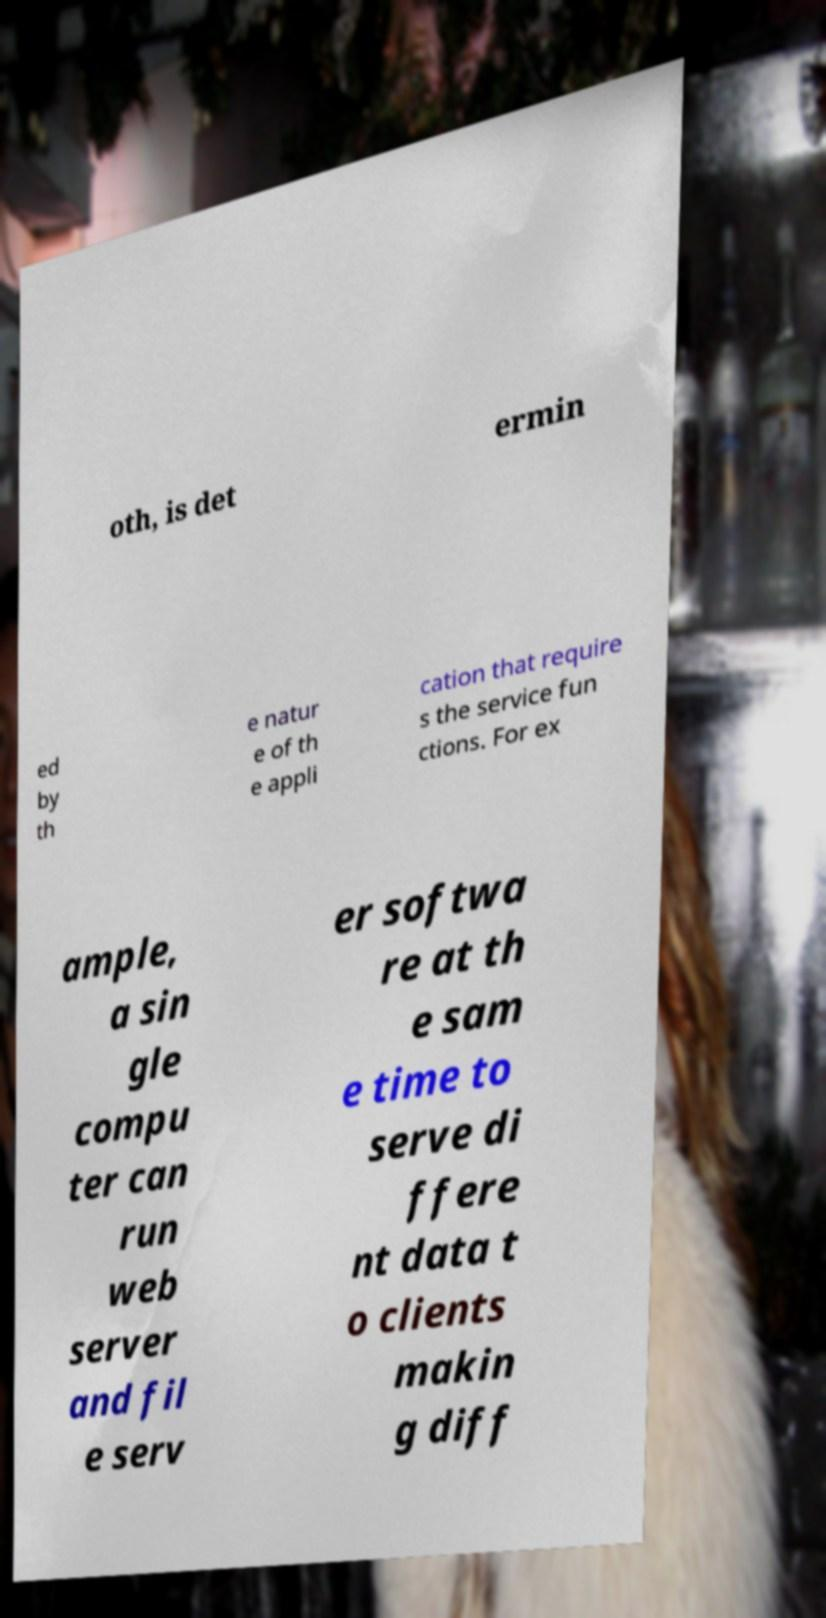I need the written content from this picture converted into text. Can you do that? oth, is det ermin ed by th e natur e of th e appli cation that require s the service fun ctions. For ex ample, a sin gle compu ter can run web server and fil e serv er softwa re at th e sam e time to serve di ffere nt data t o clients makin g diff 